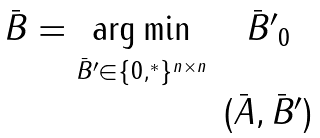<formula> <loc_0><loc_0><loc_500><loc_500>\begin{array} { c c } \bar { B } = \underset { \bar { B } ^ { \prime } \in \{ 0 , ^ { * } \} ^ { n \times n } } { \arg \min } & \| \bar { B } ^ { \prime } \| _ { 0 } \\ & ( \bar { A } , \bar { B } ^ { \prime } ) \end{array}</formula> 